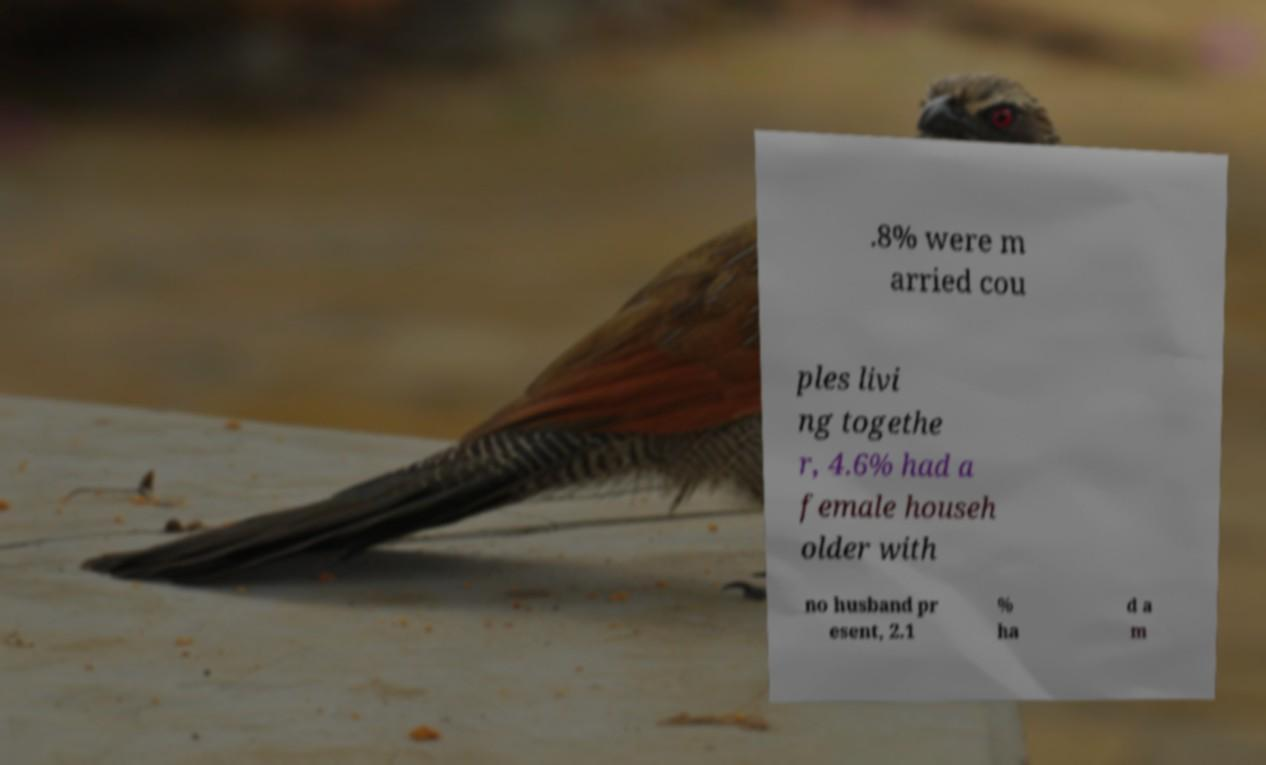Can you read and provide the text displayed in the image?This photo seems to have some interesting text. Can you extract and type it out for me? .8% were m arried cou ples livi ng togethe r, 4.6% had a female househ older with no husband pr esent, 2.1 % ha d a m 